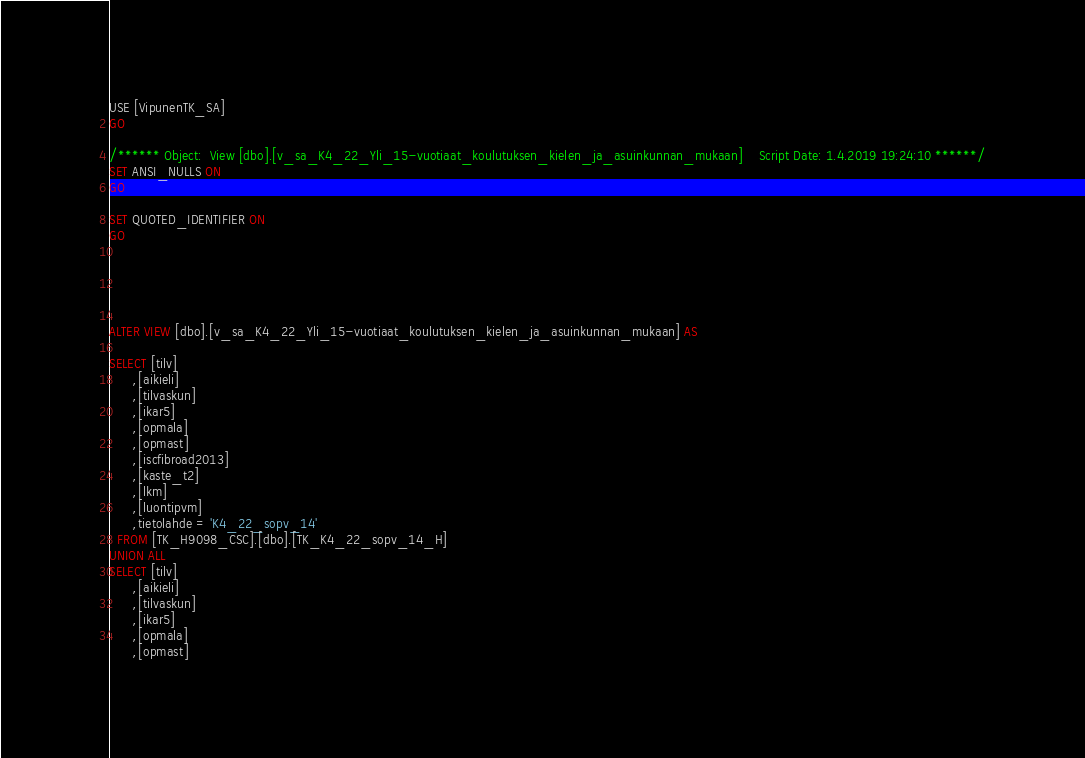<code> <loc_0><loc_0><loc_500><loc_500><_SQL_>USE [VipunenTK_SA]
GO

/****** Object:  View [dbo].[v_sa_K4_22_Yli_15-vuotiaat_koulutuksen_kielen_ja_asuinkunnan_mukaan]    Script Date: 1.4.2019 19:24:10 ******/
SET ANSI_NULLS ON
GO

SET QUOTED_IDENTIFIER ON
GO





ALTER VIEW [dbo].[v_sa_K4_22_Yli_15-vuotiaat_koulutuksen_kielen_ja_asuinkunnan_mukaan] AS

SELECT [tilv]
      ,[aikieli]
      ,[tilvaskun]
      ,[ikar5]
      ,[opmala]
      ,[opmast]
	  ,[iscfibroad2013] 
	  ,[kaste_t2] 
      ,[lkm]
      ,[luontipvm]
	  ,tietolahde = 'K4_22_sopv_14'
  FROM [TK_H9098_CSC].[dbo].[TK_K4_22_sopv_14_H]
UNION ALL
SELECT [tilv]
      ,[aikieli]
      ,[tilvaskun]
      ,[ikar5]
      ,[opmala]
      ,[opmast]</code> 